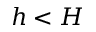<formula> <loc_0><loc_0><loc_500><loc_500>h < H</formula> 